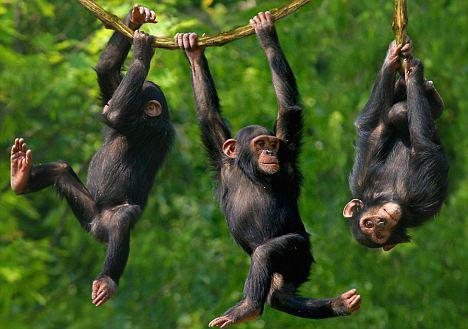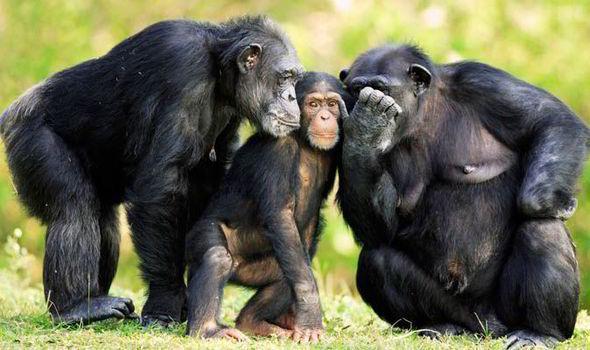The first image is the image on the left, the second image is the image on the right. For the images displayed, is the sentence "An ape is covering it's own face with at least one hand in the right image." factually correct? Answer yes or no. Yes. The first image is the image on the left, the second image is the image on the right. Evaluate the accuracy of this statement regarding the images: "Three juvenile chimps all sit in a row on the ground in the left image.". Is it true? Answer yes or no. No. 